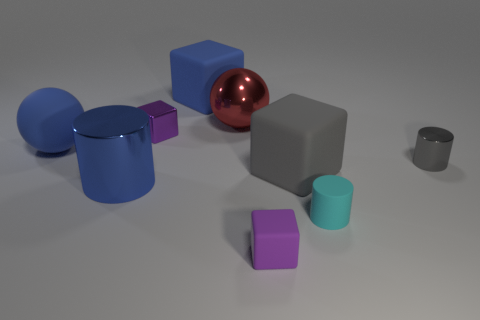Subtract all balls. How many objects are left? 7 Subtract 0 red cylinders. How many objects are left? 9 Subtract all green balls. Subtract all large gray rubber blocks. How many objects are left? 8 Add 8 tiny rubber things. How many tiny rubber things are left? 10 Add 3 metallic cylinders. How many metallic cylinders exist? 5 